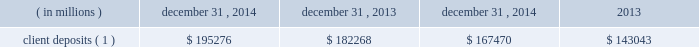Management 2019s discussion and analysis of financial condition and results of operations ( continued ) funding deposits : we provide products and services including custody , accounting , administration , daily pricing , foreign exchange services , cash management , financial asset management , securities finance and investment advisory services .
As a provider of these products and services , we generate client deposits , which have generally provided a stable , low-cost source of funds .
As a global custodian , clients place deposits with state street entities in various currencies .
We invest these client deposits in a combination of investment securities and short- duration financial instruments whose mix is determined by the characteristics of the deposits .
For the past several years , we have experienced higher client deposit inflows toward the end of the quarter or the end of the year .
As a result , we believe average client deposit balances are more reflective of ongoing funding than period-end balances .
Table 33 : client deposits average balance december 31 , year ended december 31 .
Client deposits ( 1 ) $ 195276 $ 182268 $ 167470 $ 143043 ( 1 ) balance as of december 31 , 2014 excluded term wholesale certificates of deposit , or cds , of $ 13.76 billion ; average balances for the year ended december 31 , 2014 and 2013 excluded average cds of $ 6.87 billion and $ 2.50 billion , respectively .
Short-term funding : our corporate commercial paper program , under which we can issue up to $ 3.0 billion of commercial paper with original maturities of up to 270 days from the date of issuance , had $ 2.48 billion and $ 1.82 billion of commercial paper outstanding as of december 31 , 2014 and 2013 , respectively .
Our on-balance sheet liquid assets are also an integral component of our liquidity management strategy .
These assets provide liquidity through maturities of the assets , but more importantly , they provide us with the ability to raise funds by pledging the securities as collateral for borrowings or through outright sales .
In addition , our access to the global capital markets gives us the ability to source incremental funding at reasonable rates of interest from wholesale investors .
As discussed earlier under 201casset liquidity , 201d state street bank's membership in the fhlb allows for advances of liquidity with varying terms against high-quality collateral .
Short-term secured funding also comes in the form of securities lent or sold under agreements to repurchase .
These transactions are short-term in nature , generally overnight , and are collateralized by high-quality investment securities .
These balances were $ 8.93 billion and $ 7.95 billion as of december 31 , 2014 and 2013 , respectively .
State street bank currently maintains a line of credit with a financial institution of cad $ 800 million , or approximately $ 690 million as of december 31 , 2014 , to support its canadian securities processing operations .
The line of credit has no stated termination date and is cancelable by either party with prior notice .
As of december 31 , 2014 , there was no balance outstanding on this line of credit .
Long-term funding : as of december 31 , 2014 , state street bank had board authority to issue unsecured senior debt securities from time to time , provided that the aggregate principal amount of such unsecured senior debt outstanding at any one time does not exceed $ 5 billion .
As of december 31 , 2014 , $ 4.1 billion was available for issuance pursuant to this authority .
As of december 31 , 2014 , state street bank also had board authority to issue an additional $ 500 million of subordinated debt .
We maintain an effective universal shelf registration that allows for the public offering and sale of debt securities , capital securities , common stock , depositary shares and preferred stock , and warrants to purchase such securities , including any shares into which the preferred stock and depositary shares may be convertible , or any combination thereof .
We have issued in the past , and we may issue in the future , securities pursuant to our shelf registration .
The issuance of debt or equity securities will depend on future market conditions , funding needs and other factors .
Agency credit ratings our ability to maintain consistent access to liquidity is fostered by the maintenance of high investment-grade ratings as measured by the major independent credit rating agencies .
Factors essential to maintaining high credit ratings include diverse and stable core earnings ; relative market position ; strong risk management ; strong capital ratios ; diverse liquidity sources , including the global capital markets and client deposits ; strong liquidity monitoring procedures ; and preparedness for current or future regulatory developments .
High ratings limit borrowing costs and enhance our liquidity by providing assurance for unsecured funding and depositors , increasing the potential market for our debt and improving our ability to offer products , serve markets , and engage in transactions in which clients value high credit ratings .
A downgrade or reduction of our credit ratings could have a material adverse effect on our liquidity by restricting our ability to access the capital .
What is the percent change in average cds that were excluded between 2013 and 2014? 
Rationale: i can also ask "what is the percent change in client deposits between x year and y year?" but the table has multiple labels for each year . something here is messed up .
Computations: ((6.87 - 2.50) / 2.50)
Answer: 1.748. Management 2019s discussion and analysis of financial condition and results of operations ( continued ) funding deposits : we provide products and services including custody , accounting , administration , daily pricing , foreign exchange services , cash management , financial asset management , securities finance and investment advisory services .
As a provider of these products and services , we generate client deposits , which have generally provided a stable , low-cost source of funds .
As a global custodian , clients place deposits with state street entities in various currencies .
We invest these client deposits in a combination of investment securities and short- duration financial instruments whose mix is determined by the characteristics of the deposits .
For the past several years , we have experienced higher client deposit inflows toward the end of the quarter or the end of the year .
As a result , we believe average client deposit balances are more reflective of ongoing funding than period-end balances .
Table 33 : client deposits average balance december 31 , year ended december 31 .
Client deposits ( 1 ) $ 195276 $ 182268 $ 167470 $ 143043 ( 1 ) balance as of december 31 , 2014 excluded term wholesale certificates of deposit , or cds , of $ 13.76 billion ; average balances for the year ended december 31 , 2014 and 2013 excluded average cds of $ 6.87 billion and $ 2.50 billion , respectively .
Short-term funding : our corporate commercial paper program , under which we can issue up to $ 3.0 billion of commercial paper with original maturities of up to 270 days from the date of issuance , had $ 2.48 billion and $ 1.82 billion of commercial paper outstanding as of december 31 , 2014 and 2013 , respectively .
Our on-balance sheet liquid assets are also an integral component of our liquidity management strategy .
These assets provide liquidity through maturities of the assets , but more importantly , they provide us with the ability to raise funds by pledging the securities as collateral for borrowings or through outright sales .
In addition , our access to the global capital markets gives us the ability to source incremental funding at reasonable rates of interest from wholesale investors .
As discussed earlier under 201casset liquidity , 201d state street bank's membership in the fhlb allows for advances of liquidity with varying terms against high-quality collateral .
Short-term secured funding also comes in the form of securities lent or sold under agreements to repurchase .
These transactions are short-term in nature , generally overnight , and are collateralized by high-quality investment securities .
These balances were $ 8.93 billion and $ 7.95 billion as of december 31 , 2014 and 2013 , respectively .
State street bank currently maintains a line of credit with a financial institution of cad $ 800 million , or approximately $ 690 million as of december 31 , 2014 , to support its canadian securities processing operations .
The line of credit has no stated termination date and is cancelable by either party with prior notice .
As of december 31 , 2014 , there was no balance outstanding on this line of credit .
Long-term funding : as of december 31 , 2014 , state street bank had board authority to issue unsecured senior debt securities from time to time , provided that the aggregate principal amount of such unsecured senior debt outstanding at any one time does not exceed $ 5 billion .
As of december 31 , 2014 , $ 4.1 billion was available for issuance pursuant to this authority .
As of december 31 , 2014 , state street bank also had board authority to issue an additional $ 500 million of subordinated debt .
We maintain an effective universal shelf registration that allows for the public offering and sale of debt securities , capital securities , common stock , depositary shares and preferred stock , and warrants to purchase such securities , including any shares into which the preferred stock and depositary shares may be convertible , or any combination thereof .
We have issued in the past , and we may issue in the future , securities pursuant to our shelf registration .
The issuance of debt or equity securities will depend on future market conditions , funding needs and other factors .
Agency credit ratings our ability to maintain consistent access to liquidity is fostered by the maintenance of high investment-grade ratings as measured by the major independent credit rating agencies .
Factors essential to maintaining high credit ratings include diverse and stable core earnings ; relative market position ; strong risk management ; strong capital ratios ; diverse liquidity sources , including the global capital markets and client deposits ; strong liquidity monitoring procedures ; and preparedness for current or future regulatory developments .
High ratings limit borrowing costs and enhance our liquidity by providing assurance for unsecured funding and depositors , increasing the potential market for our debt and improving our ability to offer products , serve markets , and engage in transactions in which clients value high credit ratings .
A downgrade or reduction of our credit ratings could have a material adverse effect on our liquidity by restricting our ability to access the capital .
What is the growth rate in the deposits of clients from 2013 to 2014? 
Computations: ((195276 - 182268) / 182268)
Answer: 0.07137. 